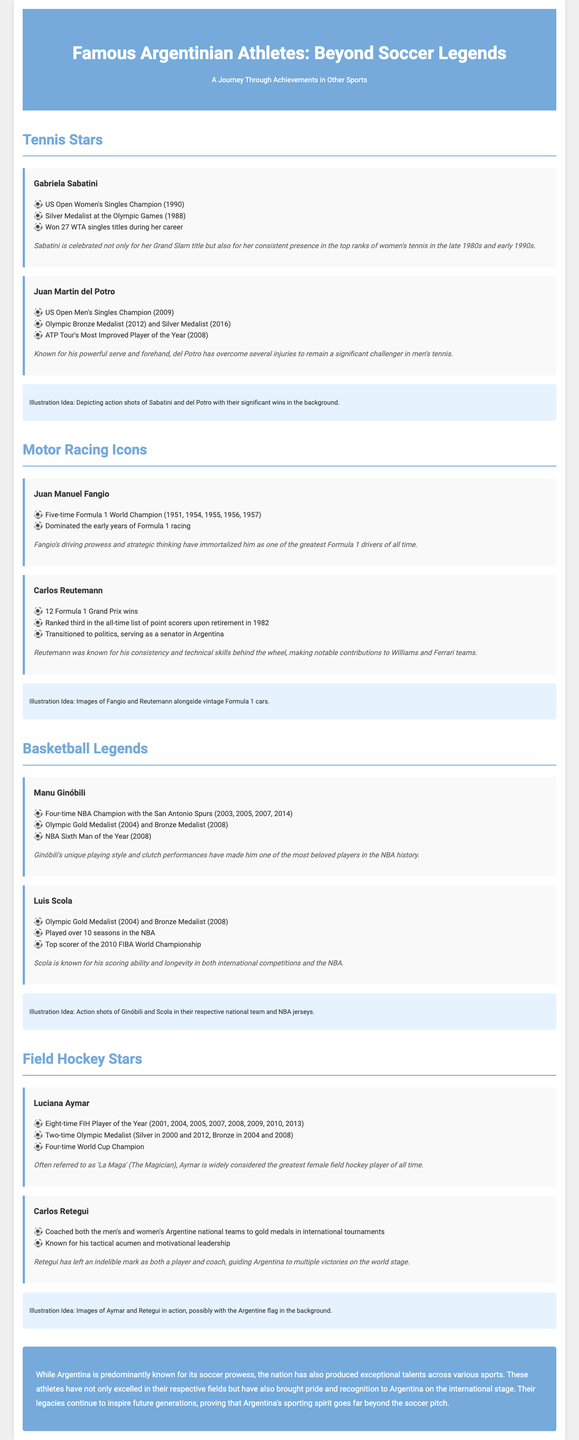What is Gabriela Sabatini's notable achievement? Gabriela Sabatini won the US Open Women's Singles Champion in 1990, which is highlighted in her achievements.
Answer: US Open Women's Singles Champion (1990) How many Formula 1 World Championships did Juan Manuel Fangio win? The document states that Juan Manuel Fangio was a five-time Formula 1 World Champion, indicating his level of success in the sport.
Answer: Five-time Formula 1 World Champion What sport is Carlos Retegui associated with? The information in the document identifies Carlos Retegui as a key figure in field hockey, specifically for his coaching abilities.
Answer: Field Hockey How many Olympic medals did Luciana Aymar earn? The document details that Luciana Aymar is a two-time Olympic Medalist, thus showcasing her achievements in Olympic competitions.
Answer: Two-time Olympic Medalist What year did Juan Martin del Potro win the US Open? The document explicitly mentions that Juan Martin del Potro won the US Open Men's Singles Championship in 2009.
Answer: 2009 How many times was Luciana Aymar named FIH Player of the Year? The infographic lists that Luciana Aymar earned the title of FIH Player of the Year eight times, which is a significant achievement in field hockey.
Answer: Eight-time FIH Player of the Year What is a common achievement between Manu Ginóbili and Luis Scola? Both athletes won Olympic medals, as detailed in their respective achievement lists in the document, highlighting their international success.
Answer: Olympic Gold Medalist (2004) What is the main theme of the infographic? The document focuses on celebrating famous Argentine athletes beyond soccer, showcasing achievements across various sports.
Answer: Famous Argentinian Athletes: Beyond Soccer Legends What year did Carlos Reutemann transition to politics? The document mentions that Carlos Reutemann transitioned to politics after he retired in 1982, linking his sports career with his political endeavors.
Answer: 1982 